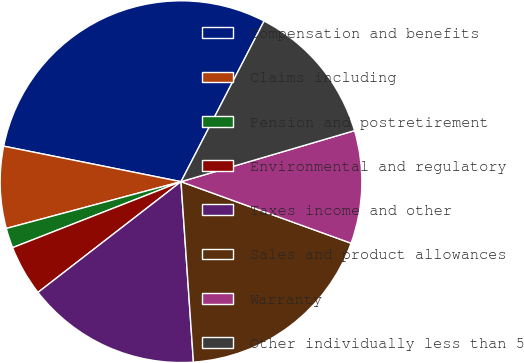<chart> <loc_0><loc_0><loc_500><loc_500><pie_chart><fcel>Compensation and benefits<fcel>Claims including<fcel>Pension and postretirement<fcel>Environmental and regulatory<fcel>Taxes income and other<fcel>Sales and product allowances<fcel>Warranty<fcel>Other individually less than 5<nl><fcel>29.45%<fcel>7.31%<fcel>1.78%<fcel>4.54%<fcel>15.61%<fcel>18.38%<fcel>10.08%<fcel>12.85%<nl></chart> 